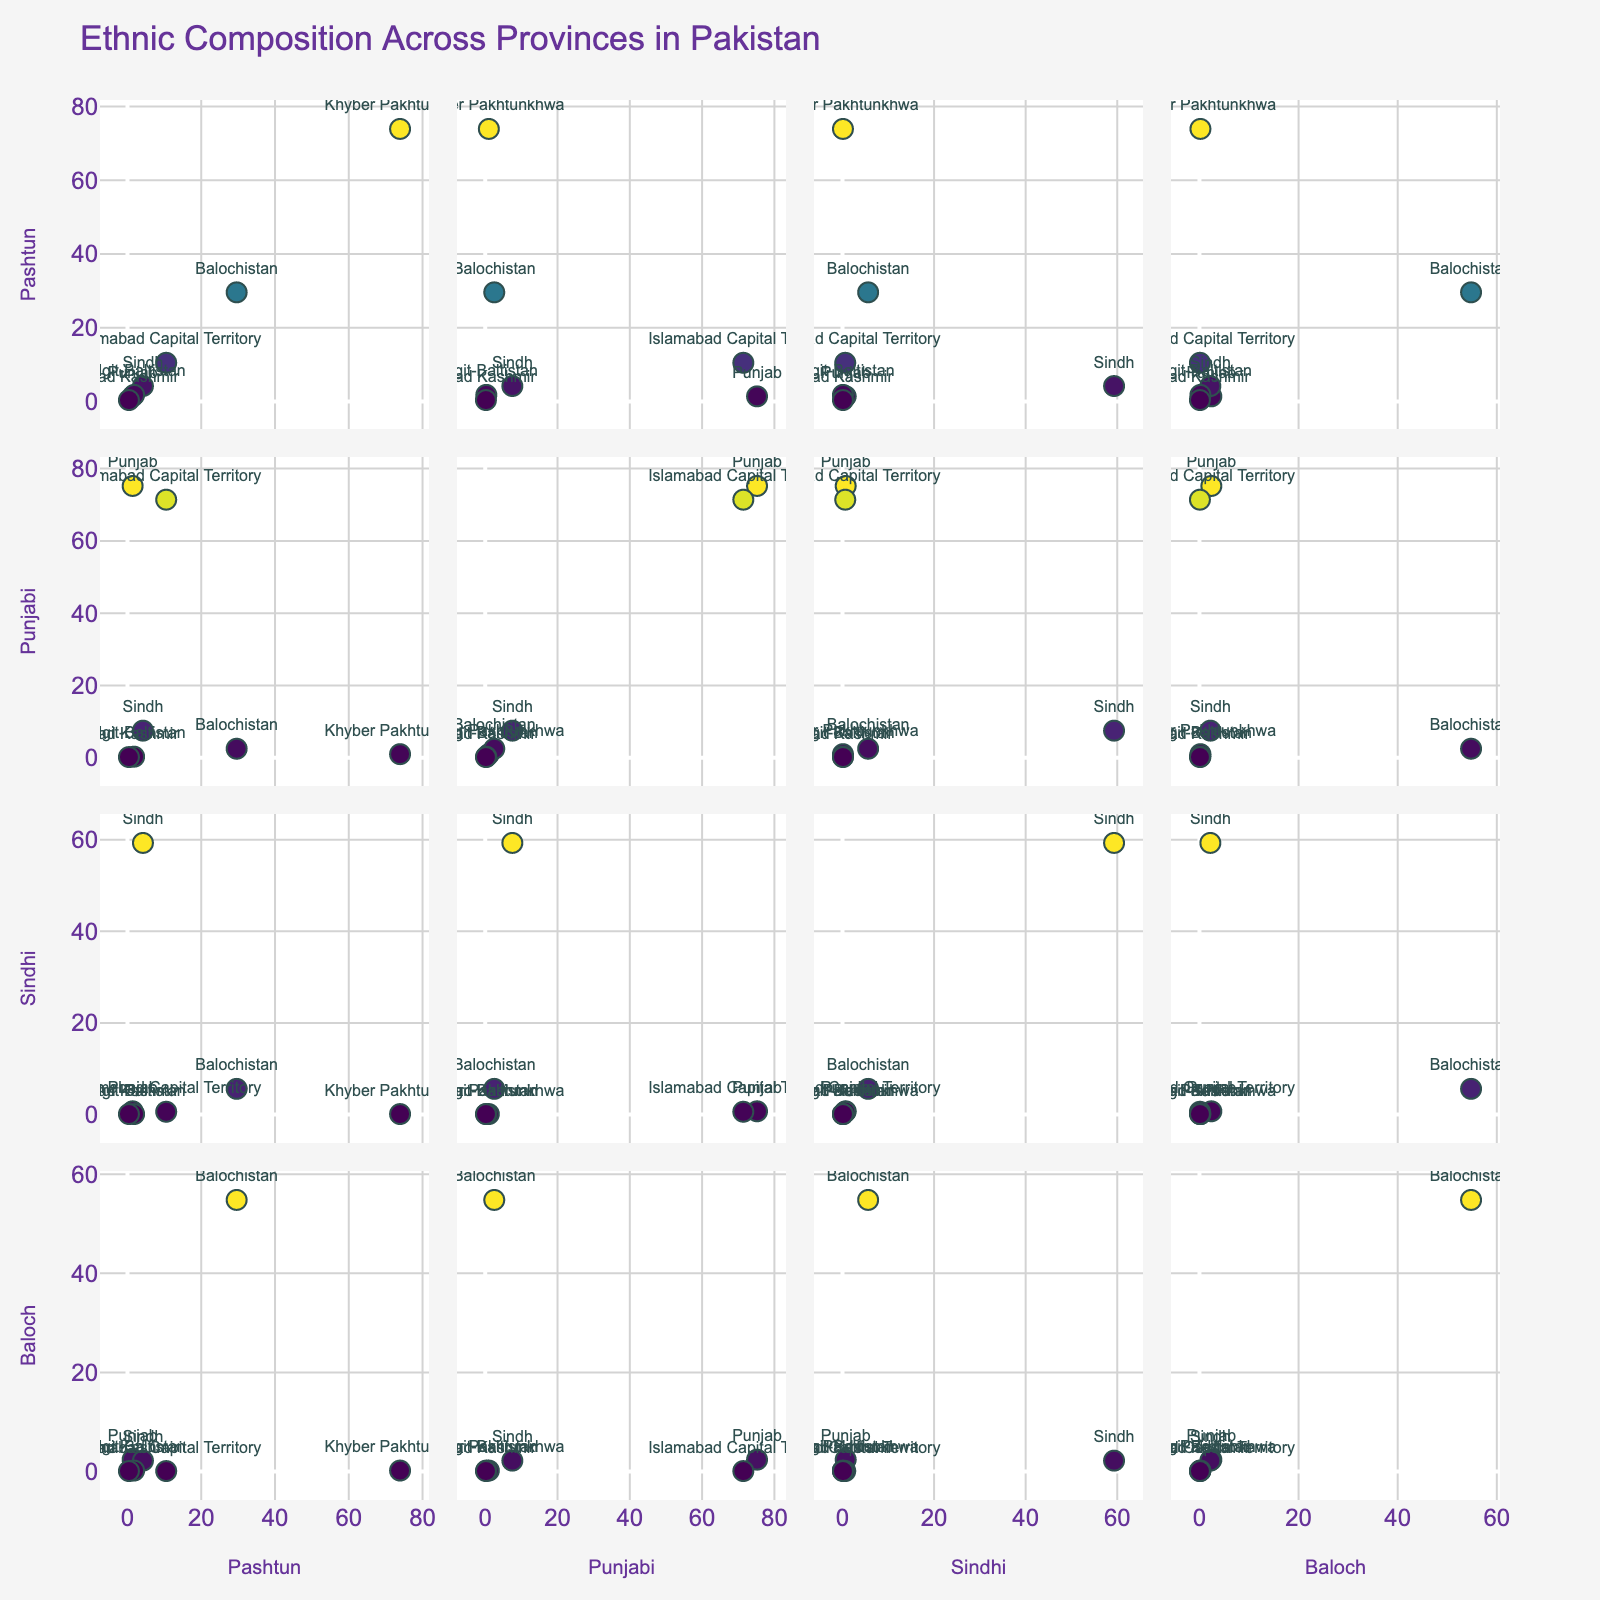What is the title of the scatterplot matrix? The title of the scatterplot is displayed at the top of the figure. It provides a summary or main topic of the plot. In this case, the plot visualizes the ethnic composition across Pakistani provinces.
Answer: Ethnic Composition Across Provinces in Pakistan Which province has the highest percentage of Pashtuns? By examining the scatter points along the y-axis for "Pashtun," we can identify which point reaches the highest value. In this plot, Khyber Pakhtunkhwa has the highest percentage.
Answer: Khyber Pakhtunkhwa How many provinces have more than 50% of any ethnic group? To determine this, we need to count the number of scatter points that exceed 50% along any axis representing Pashtun, Punjabi, Sindhi, or Baloch. Khyber Pakhtunkhwa, Punjab, Sindh, and Balochistan each have more than 50% in one ethnic group.
Answer: 4 Which province has the smallest percentage of Sindhi population, and what is that percentage? To find this, look at the positions of scatter points along the x-axis labeled "Sindhi" and identify the lowest value. Azad Kashmir has the smallest percentage of Sindhi population.
Answer: Azad Kashmir, 0.1% Are there any provinces with a high percentage of both Pashtun and Baloch populations? On the scatter plot where Pashtun and Baloch are charted, look for points that are high on both the x-axis and y-axis. Balochistan has relatively high values for both Pashtun and Baloch populations.
Answer: Balochistan How many provinces have a lower Baloch population than Islamabab Capital Territory? Find the position of Islamabad Capital Territory's Baloch percentage and count the number of scatter points below that level on the y-axis labeled "Baloch." Since Islamabad Capital Territory has 0.1% Baloch population, it is higher than Gilgit-Baltistan and Azad Kashmir.
Answer: 2 Which ethnicity has the highest representation in Balochistan, and what is that percentage? Examine the rows/columns where Balochistan is labeled to find the maximum value among Pashtun, Punjabi, Sindhi, and Baloch. Here, Baloch has the highest percentage.
Answer: Baloch, 54.8% Do any provinces have a similar percentage of Punjabi and Sindhi populations? Compare the scatter points on the scatter plots where Punjabi and Sindhi percentages are plotted against each other. Provinces whose points lie close to the 45-degree line have similar percentages for these two groups. Islamabad Capital Territory shows similar percentages of Punjabi and Sindhi.
Answer: Islamabad Capital Territory 